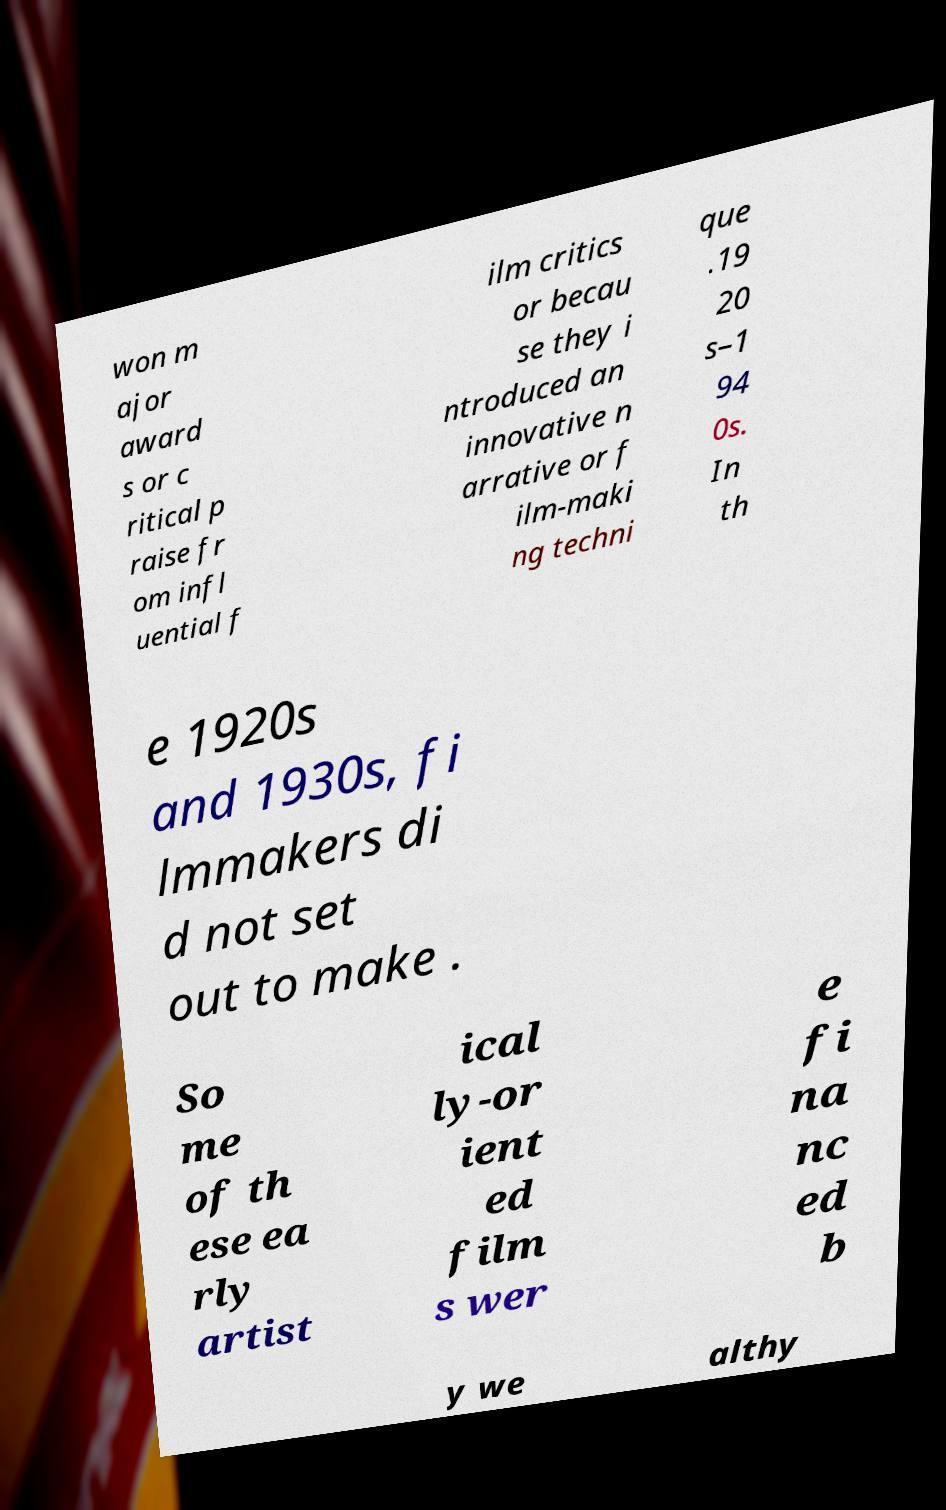Can you accurately transcribe the text from the provided image for me? won m ajor award s or c ritical p raise fr om infl uential f ilm critics or becau se they i ntroduced an innovative n arrative or f ilm-maki ng techni que .19 20 s–1 94 0s. In th e 1920s and 1930s, fi lmmakers di d not set out to make . So me of th ese ea rly artist ical ly-or ient ed film s wer e fi na nc ed b y we althy 